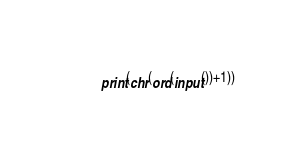<code> <loc_0><loc_0><loc_500><loc_500><_Python_>print(chr(ord(input())+1))</code> 